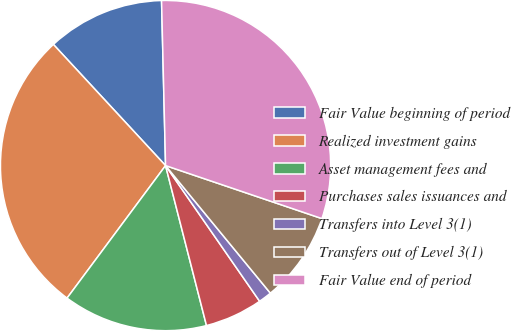Convert chart to OTSL. <chart><loc_0><loc_0><loc_500><loc_500><pie_chart><fcel>Fair Value beginning of period<fcel>Realized investment gains<fcel>Asset management fees and<fcel>Purchases sales issuances and<fcel>Transfers into Level 3(1)<fcel>Transfers out of Level 3(1)<fcel>Fair Value end of period<nl><fcel>11.5%<fcel>27.94%<fcel>14.16%<fcel>5.66%<fcel>1.3%<fcel>8.85%<fcel>30.59%<nl></chart> 